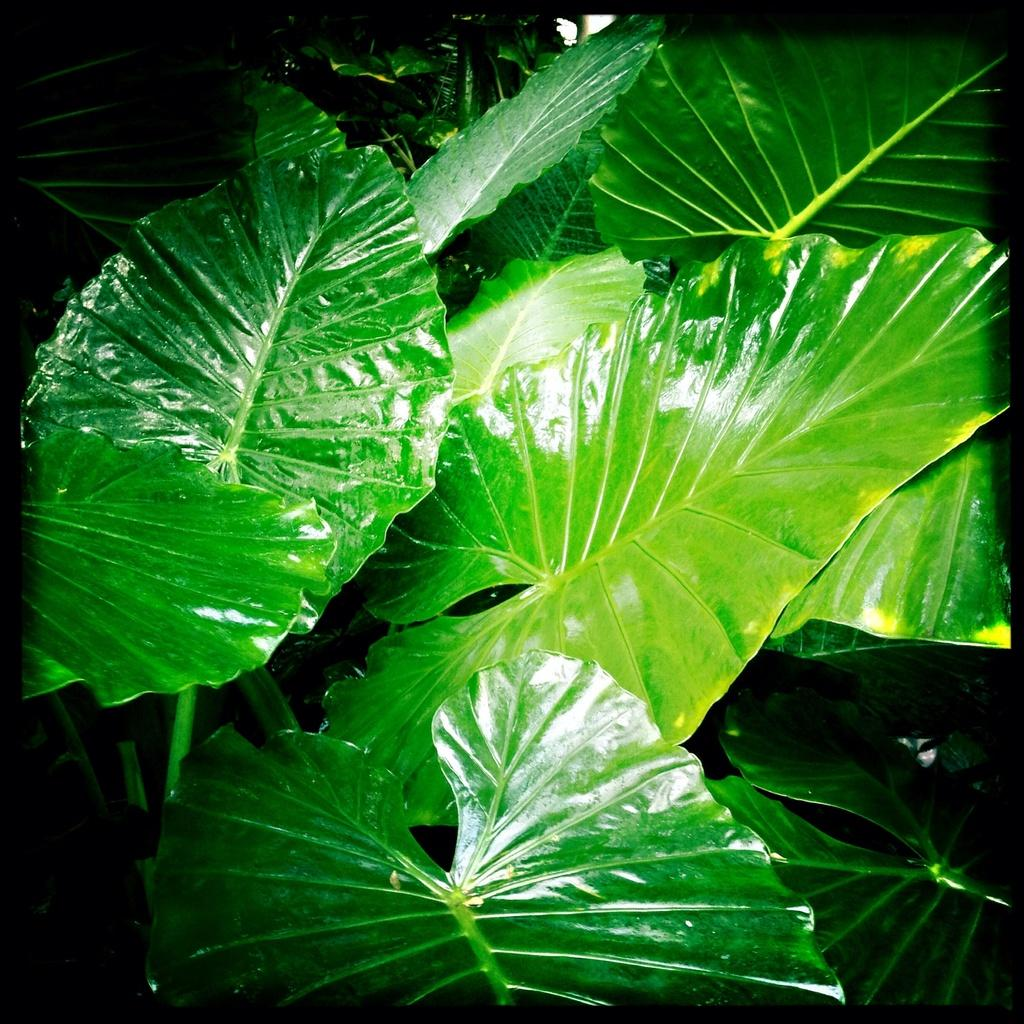What type of living organisms can be seen in the image? Plants can be seen in the image. Can you describe any additional features of the image? The image is an edited picture. How many snails are sitting on the chairs in the image? There are no snails or chairs present in the image. 